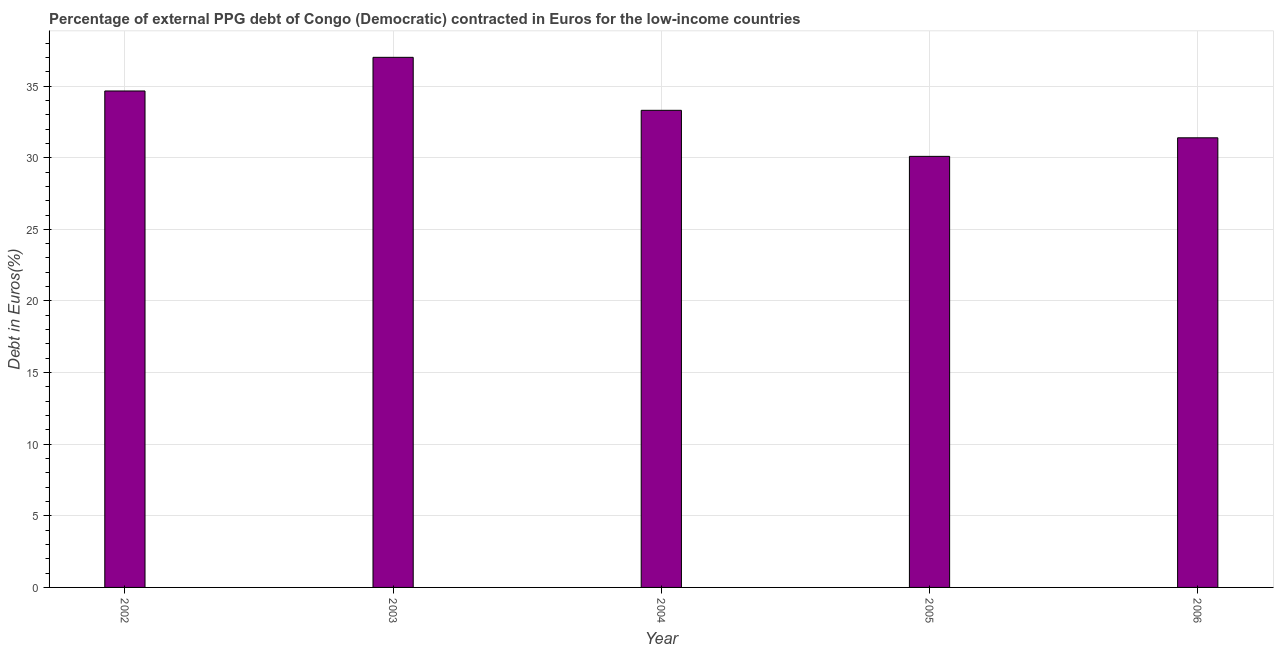Does the graph contain grids?
Your response must be concise. Yes. What is the title of the graph?
Make the answer very short. Percentage of external PPG debt of Congo (Democratic) contracted in Euros for the low-income countries. What is the label or title of the Y-axis?
Your response must be concise. Debt in Euros(%). What is the currency composition of ppg debt in 2005?
Provide a succinct answer. 30.09. Across all years, what is the maximum currency composition of ppg debt?
Your response must be concise. 37.01. Across all years, what is the minimum currency composition of ppg debt?
Offer a terse response. 30.09. In which year was the currency composition of ppg debt minimum?
Offer a very short reply. 2005. What is the sum of the currency composition of ppg debt?
Make the answer very short. 166.46. What is the difference between the currency composition of ppg debt in 2003 and 2005?
Offer a very short reply. 6.92. What is the average currency composition of ppg debt per year?
Your response must be concise. 33.29. What is the median currency composition of ppg debt?
Provide a succinct answer. 33.31. In how many years, is the currency composition of ppg debt greater than 32 %?
Offer a very short reply. 3. Do a majority of the years between 2003 and 2006 (inclusive) have currency composition of ppg debt greater than 13 %?
Offer a terse response. Yes. Is the currency composition of ppg debt in 2002 less than that in 2004?
Give a very brief answer. No. Is the difference between the currency composition of ppg debt in 2002 and 2006 greater than the difference between any two years?
Provide a succinct answer. No. What is the difference between the highest and the second highest currency composition of ppg debt?
Provide a succinct answer. 2.35. Is the sum of the currency composition of ppg debt in 2005 and 2006 greater than the maximum currency composition of ppg debt across all years?
Your response must be concise. Yes. What is the difference between the highest and the lowest currency composition of ppg debt?
Ensure brevity in your answer.  6.91. In how many years, is the currency composition of ppg debt greater than the average currency composition of ppg debt taken over all years?
Make the answer very short. 3. How many years are there in the graph?
Offer a terse response. 5. Are the values on the major ticks of Y-axis written in scientific E-notation?
Provide a short and direct response. No. What is the Debt in Euros(%) in 2002?
Your answer should be very brief. 34.66. What is the Debt in Euros(%) of 2003?
Provide a short and direct response. 37.01. What is the Debt in Euros(%) in 2004?
Ensure brevity in your answer.  33.31. What is the Debt in Euros(%) in 2005?
Make the answer very short. 30.09. What is the Debt in Euros(%) of 2006?
Your response must be concise. 31.39. What is the difference between the Debt in Euros(%) in 2002 and 2003?
Offer a very short reply. -2.35. What is the difference between the Debt in Euros(%) in 2002 and 2004?
Keep it short and to the point. 1.35. What is the difference between the Debt in Euros(%) in 2002 and 2005?
Your response must be concise. 4.57. What is the difference between the Debt in Euros(%) in 2002 and 2006?
Your answer should be compact. 3.27. What is the difference between the Debt in Euros(%) in 2003 and 2004?
Your response must be concise. 3.7. What is the difference between the Debt in Euros(%) in 2003 and 2005?
Give a very brief answer. 6.91. What is the difference between the Debt in Euros(%) in 2003 and 2006?
Provide a short and direct response. 5.62. What is the difference between the Debt in Euros(%) in 2004 and 2005?
Provide a short and direct response. 3.22. What is the difference between the Debt in Euros(%) in 2004 and 2006?
Offer a terse response. 1.92. What is the difference between the Debt in Euros(%) in 2005 and 2006?
Provide a short and direct response. -1.3. What is the ratio of the Debt in Euros(%) in 2002 to that in 2003?
Keep it short and to the point. 0.94. What is the ratio of the Debt in Euros(%) in 2002 to that in 2004?
Your answer should be very brief. 1.04. What is the ratio of the Debt in Euros(%) in 2002 to that in 2005?
Your response must be concise. 1.15. What is the ratio of the Debt in Euros(%) in 2002 to that in 2006?
Offer a very short reply. 1.1. What is the ratio of the Debt in Euros(%) in 2003 to that in 2004?
Your answer should be compact. 1.11. What is the ratio of the Debt in Euros(%) in 2003 to that in 2005?
Provide a short and direct response. 1.23. What is the ratio of the Debt in Euros(%) in 2003 to that in 2006?
Your answer should be very brief. 1.18. What is the ratio of the Debt in Euros(%) in 2004 to that in 2005?
Offer a terse response. 1.11. What is the ratio of the Debt in Euros(%) in 2004 to that in 2006?
Provide a short and direct response. 1.06. 